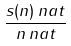<formula> <loc_0><loc_0><loc_500><loc_500>\frac { s ( n ) \, { n a t } } { n \, { n a t } }</formula> 